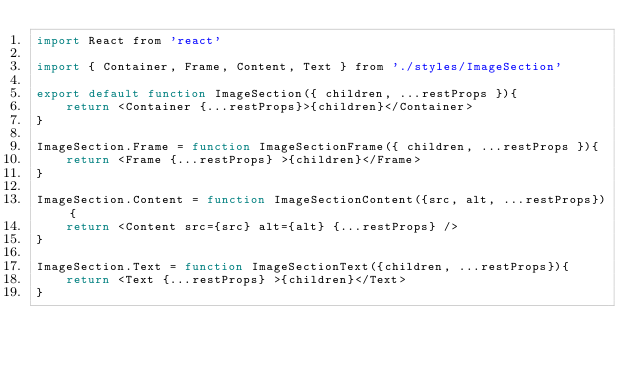<code> <loc_0><loc_0><loc_500><loc_500><_JavaScript_>import React from 'react'

import { Container, Frame, Content, Text } from './styles/ImageSection'

export default function ImageSection({ children, ...restProps }){
    return <Container {...restProps}>{children}</Container>
}

ImageSection.Frame = function ImageSectionFrame({ children, ...restProps }){
    return <Frame {...restProps} >{children}</Frame>
}

ImageSection.Content = function ImageSectionContent({src, alt, ...restProps}){
    return <Content src={src} alt={alt} {...restProps} />
}

ImageSection.Text = function ImageSectionText({children, ...restProps}){
    return <Text {...restProps} >{children}</Text>
}</code> 